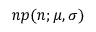<formula> <loc_0><loc_0><loc_500><loc_500>n p ( n ; \mu , \sigma )</formula> 